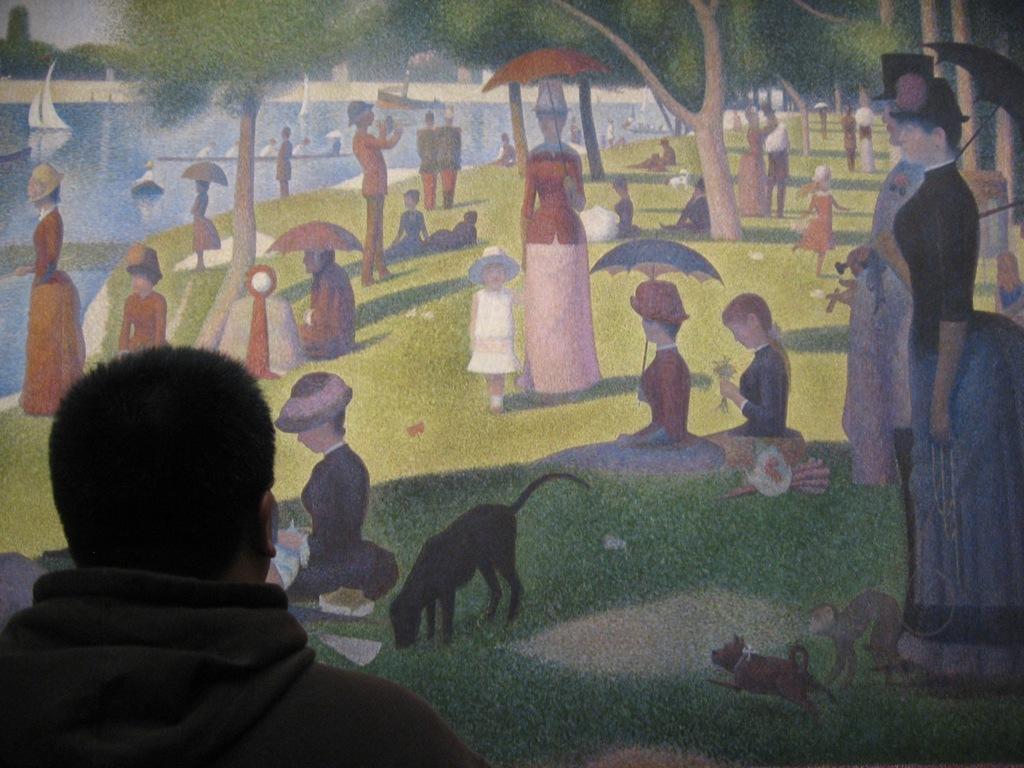Can you describe this image briefly? In this image there is a person standing in front of the painting, in which there are a few people sitting and standing on the surface of the grass, a few are holding umbrellas and a few are wearing hats on their head, there are two dogs and few objects on the surface, there are trees and a few boats on the river. 